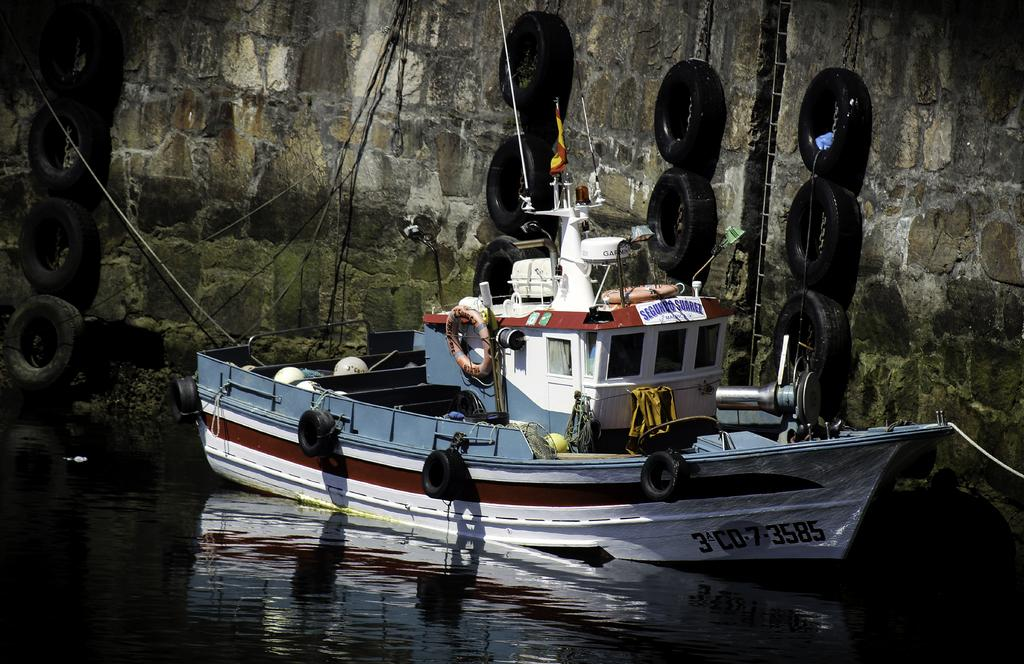What is located at the bottom of the image? There is a water body at the bottom of the image. What can be seen in the middle of the image? There is a boat in the middle of the image. What objects are present at the top of the image? There are tyres and a wall at the top of the image. What type of eggnog is being discussed in the image? There is no discussion or eggnog present in the image. Can you see any twigs in the image? There are no twigs visible in the image. 